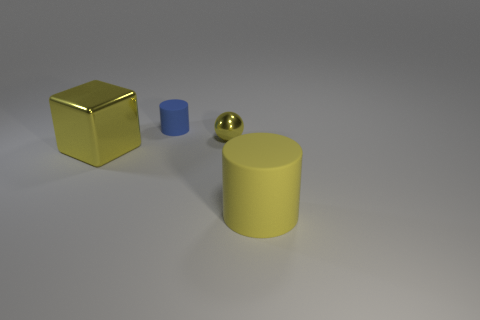Add 2 large cubes. How many objects exist? 6 Subtract all cubes. How many objects are left? 3 Subtract 0 green spheres. How many objects are left? 4 Subtract all red metal balls. Subtract all small balls. How many objects are left? 3 Add 2 small things. How many small things are left? 4 Add 4 small purple rubber cylinders. How many small purple rubber cylinders exist? 4 